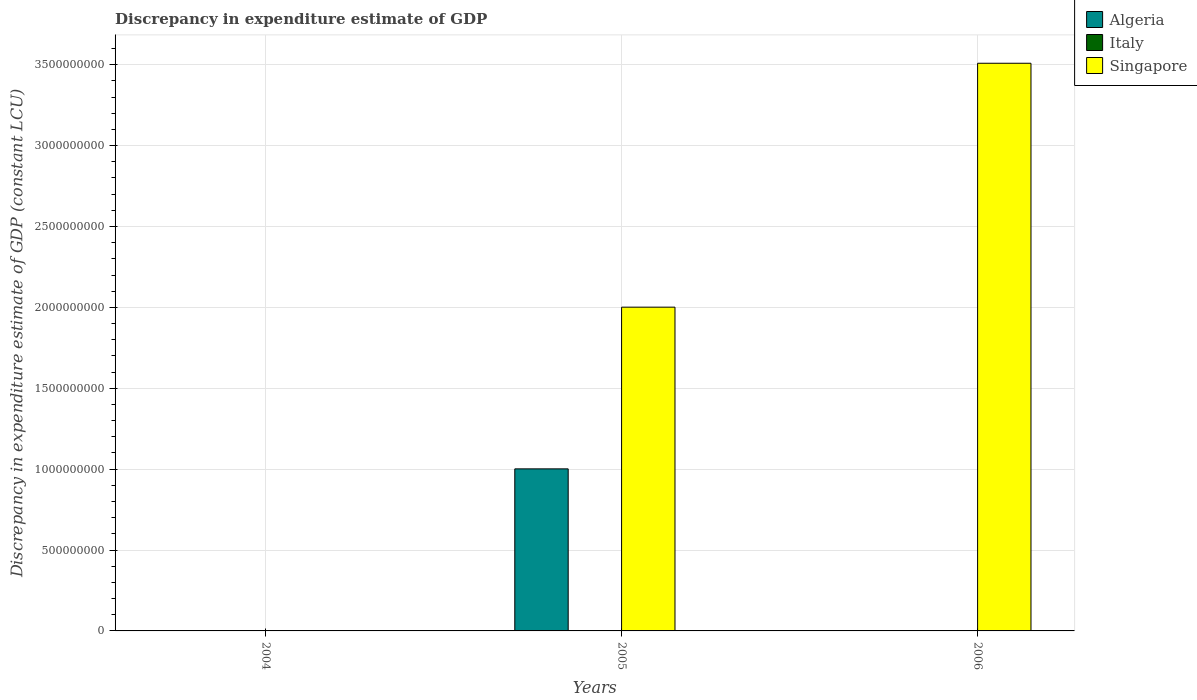In how many cases, is the number of bars for a given year not equal to the number of legend labels?
Provide a succinct answer. 3. What is the discrepancy in expenditure estimate of GDP in Singapore in 2005?
Keep it short and to the point. 2.00e+09. Across all years, what is the maximum discrepancy in expenditure estimate of GDP in Singapore?
Your answer should be very brief. 3.51e+09. Across all years, what is the minimum discrepancy in expenditure estimate of GDP in Italy?
Your response must be concise. 0. What is the total discrepancy in expenditure estimate of GDP in Singapore in the graph?
Provide a succinct answer. 5.51e+09. What is the difference between the discrepancy in expenditure estimate of GDP in Singapore in 2005 and that in 2006?
Keep it short and to the point. -1.51e+09. What is the difference between the discrepancy in expenditure estimate of GDP in Italy in 2005 and the discrepancy in expenditure estimate of GDP in Algeria in 2004?
Give a very brief answer. 0. In the year 2005, what is the difference between the discrepancy in expenditure estimate of GDP in Algeria and discrepancy in expenditure estimate of GDP in Singapore?
Provide a short and direct response. -1.00e+09. What is the difference between the highest and the lowest discrepancy in expenditure estimate of GDP in Algeria?
Your answer should be very brief. 1.00e+09. In how many years, is the discrepancy in expenditure estimate of GDP in Algeria greater than the average discrepancy in expenditure estimate of GDP in Algeria taken over all years?
Keep it short and to the point. 1. Is it the case that in every year, the sum of the discrepancy in expenditure estimate of GDP in Singapore and discrepancy in expenditure estimate of GDP in Algeria is greater than the discrepancy in expenditure estimate of GDP in Italy?
Make the answer very short. No. Are all the bars in the graph horizontal?
Your response must be concise. No. How many years are there in the graph?
Offer a very short reply. 3. What is the difference between two consecutive major ticks on the Y-axis?
Keep it short and to the point. 5.00e+08. Does the graph contain any zero values?
Keep it short and to the point. Yes. Where does the legend appear in the graph?
Provide a succinct answer. Top right. What is the title of the graph?
Make the answer very short. Discrepancy in expenditure estimate of GDP. What is the label or title of the X-axis?
Provide a succinct answer. Years. What is the label or title of the Y-axis?
Your answer should be very brief. Discrepancy in expenditure estimate of GDP (constant LCU). What is the Discrepancy in expenditure estimate of GDP (constant LCU) of Algeria in 2004?
Ensure brevity in your answer.  0. What is the Discrepancy in expenditure estimate of GDP (constant LCU) of Singapore in 2004?
Your answer should be compact. 0. What is the Discrepancy in expenditure estimate of GDP (constant LCU) of Algeria in 2005?
Offer a very short reply. 1.00e+09. What is the Discrepancy in expenditure estimate of GDP (constant LCU) in Italy in 2005?
Your answer should be very brief. 0. What is the Discrepancy in expenditure estimate of GDP (constant LCU) in Singapore in 2005?
Ensure brevity in your answer.  2.00e+09. What is the Discrepancy in expenditure estimate of GDP (constant LCU) of Algeria in 2006?
Ensure brevity in your answer.  0. What is the Discrepancy in expenditure estimate of GDP (constant LCU) in Singapore in 2006?
Offer a very short reply. 3.51e+09. Across all years, what is the maximum Discrepancy in expenditure estimate of GDP (constant LCU) in Algeria?
Offer a very short reply. 1.00e+09. Across all years, what is the maximum Discrepancy in expenditure estimate of GDP (constant LCU) in Singapore?
Your response must be concise. 3.51e+09. What is the total Discrepancy in expenditure estimate of GDP (constant LCU) of Algeria in the graph?
Provide a succinct answer. 1.00e+09. What is the total Discrepancy in expenditure estimate of GDP (constant LCU) in Singapore in the graph?
Keep it short and to the point. 5.51e+09. What is the difference between the Discrepancy in expenditure estimate of GDP (constant LCU) of Singapore in 2005 and that in 2006?
Make the answer very short. -1.51e+09. What is the difference between the Discrepancy in expenditure estimate of GDP (constant LCU) of Algeria in 2005 and the Discrepancy in expenditure estimate of GDP (constant LCU) of Singapore in 2006?
Ensure brevity in your answer.  -2.51e+09. What is the average Discrepancy in expenditure estimate of GDP (constant LCU) of Algeria per year?
Your response must be concise. 3.34e+08. What is the average Discrepancy in expenditure estimate of GDP (constant LCU) of Italy per year?
Offer a very short reply. 0. What is the average Discrepancy in expenditure estimate of GDP (constant LCU) of Singapore per year?
Provide a succinct answer. 1.84e+09. In the year 2005, what is the difference between the Discrepancy in expenditure estimate of GDP (constant LCU) of Algeria and Discrepancy in expenditure estimate of GDP (constant LCU) of Singapore?
Ensure brevity in your answer.  -1.00e+09. What is the ratio of the Discrepancy in expenditure estimate of GDP (constant LCU) of Singapore in 2005 to that in 2006?
Offer a terse response. 0.57. What is the difference between the highest and the lowest Discrepancy in expenditure estimate of GDP (constant LCU) of Algeria?
Provide a succinct answer. 1.00e+09. What is the difference between the highest and the lowest Discrepancy in expenditure estimate of GDP (constant LCU) in Singapore?
Give a very brief answer. 3.51e+09. 